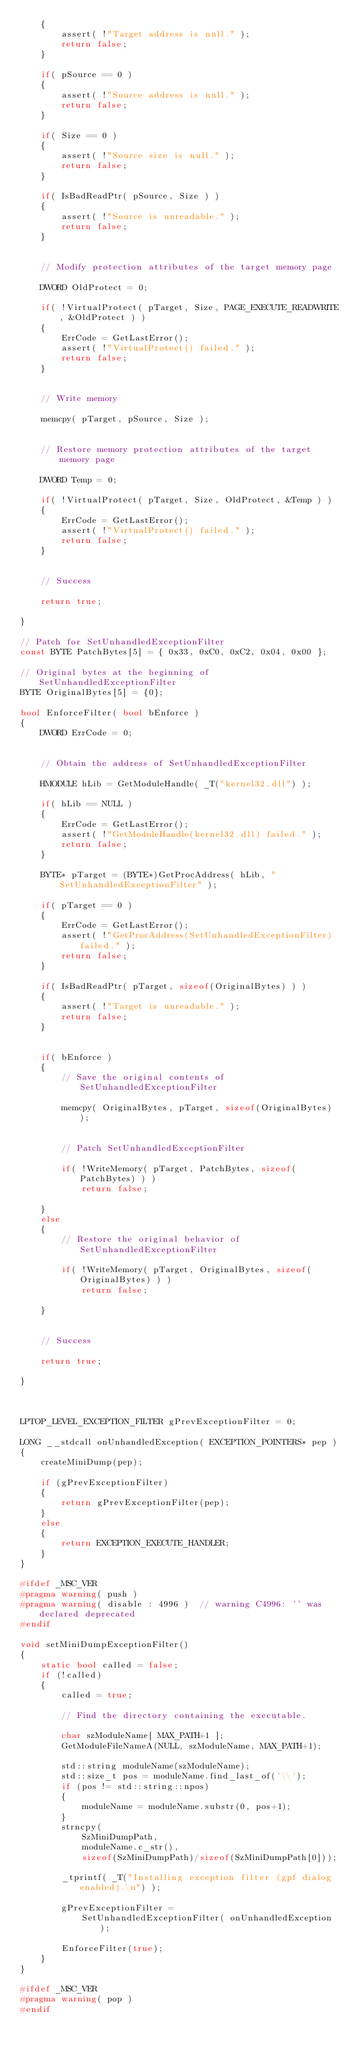Convert code to text. <code><loc_0><loc_0><loc_500><loc_500><_C++_>    {
        assert( !"Target address is null." );
        return false;
    }

    if( pSource == 0 )
    {
        assert( !"Source address is null." );
        return false;
    }

    if( Size == 0 )
    {
        assert( !"Source size is null." );
        return false;
    }

    if( IsBadReadPtr( pSource, Size ) )
    {
        assert( !"Source is unreadable." );
        return false;
    }


    // Modify protection attributes of the target memory page 

    DWORD OldProtect = 0;

    if( !VirtualProtect( pTarget, Size, PAGE_EXECUTE_READWRITE, &OldProtect ) )
    {
        ErrCode = GetLastError();
        assert( !"VirtualProtect() failed." );
        return false;
    }


    // Write memory 

    memcpy( pTarget, pSource, Size );


    // Restore memory protection attributes of the target memory page 

    DWORD Temp = 0;

    if( !VirtualProtect( pTarget, Size, OldProtect, &Temp ) )
    {
        ErrCode = GetLastError();
        assert( !"VirtualProtect() failed." );
        return false;
    }


    // Success 

    return true;

}

// Patch for SetUnhandledExceptionFilter 
const BYTE PatchBytes[5] = { 0x33, 0xC0, 0xC2, 0x04, 0x00 };

// Original bytes at the beginning of SetUnhandledExceptionFilter 
BYTE OriginalBytes[5] = {0};

bool EnforceFilter( bool bEnforce )
{
    DWORD ErrCode = 0;


    // Obtain the address of SetUnhandledExceptionFilter 

    HMODULE hLib = GetModuleHandle( _T("kernel32.dll") );

    if( hLib == NULL )
    {
        ErrCode = GetLastError();
        assert( !"GetModuleHandle(kernel32.dll) failed." );
        return false;
    }

    BYTE* pTarget = (BYTE*)GetProcAddress( hLib, "SetUnhandledExceptionFilter" );

    if( pTarget == 0 )
    {
        ErrCode = GetLastError();
        assert( !"GetProcAddress(SetUnhandledExceptionFilter) failed." );
        return false;
    }

    if( IsBadReadPtr( pTarget, sizeof(OriginalBytes) ) )
    {
        assert( !"Target is unreadable." );
        return false;
    }


    if( bEnforce )
    {
        // Save the original contents of SetUnhandledExceptionFilter 

        memcpy( OriginalBytes, pTarget, sizeof(OriginalBytes) );


        // Patch SetUnhandledExceptionFilter 

        if( !WriteMemory( pTarget, PatchBytes, sizeof(PatchBytes) ) )
            return false;

    }
    else
    {
        // Restore the original behavior of SetUnhandledExceptionFilter 

        if( !WriteMemory( pTarget, OriginalBytes, sizeof(OriginalBytes) ) )
            return false;

    }


    // Success 

    return true;

}



LPTOP_LEVEL_EXCEPTION_FILTER gPrevExceptionFilter = 0;

LONG __stdcall onUnhandledException( EXCEPTION_POINTERS* pep ) 
{
    createMiniDump(pep); 

    if (gPrevExceptionFilter)
    {
        return gPrevExceptionFilter(pep);
    }
    else
    {
        return EXCEPTION_EXECUTE_HANDLER; 
    }
}

#ifdef _MSC_VER
#pragma warning( push )
#pragma warning( disable : 4996 )  // warning C4996: '' was declared deprecated
#endif

void setMiniDumpExceptionFilter()
{
    static bool called = false;
    if (!called)
    {
        called = true;

        // Find the directory containing the executable.

        char szModuleName[ MAX_PATH+1 ];
        GetModuleFileNameA(NULL, szModuleName, MAX_PATH+1);

        std::string moduleName(szModuleName);
        std::size_t pos = moduleName.find_last_of('\\');
        if (pos != std::string::npos)
        {
            moduleName = moduleName.substr(0, pos+1);
        }
        strncpy(
            SzMiniDumpPath, 
            moduleName.c_str(), 
            sizeof(SzMiniDumpPath)/sizeof(SzMiniDumpPath[0]));

        _tprintf( _T("Installing exception filter (gpf dialog enabled).\n") ); 

        gPrevExceptionFilter = 
            SetUnhandledExceptionFilter( onUnhandledException );

        EnforceFilter(true);
    }
}

#ifdef _MSC_VER
#pragma warning( pop )
#endif
</code> 